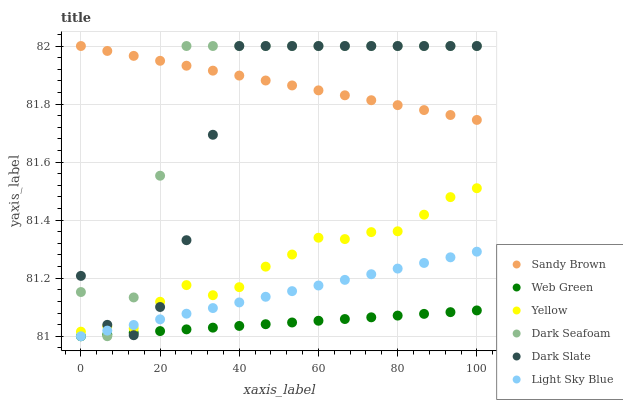Does Web Green have the minimum area under the curve?
Answer yes or no. Yes. Does Sandy Brown have the maximum area under the curve?
Answer yes or no. Yes. Does Dark Slate have the minimum area under the curve?
Answer yes or no. No. Does Dark Slate have the maximum area under the curve?
Answer yes or no. No. Is Web Green the smoothest?
Answer yes or no. Yes. Is Dark Seafoam the roughest?
Answer yes or no. Yes. Is Dark Slate the smoothest?
Answer yes or no. No. Is Dark Slate the roughest?
Answer yes or no. No. Does Light Sky Blue have the lowest value?
Answer yes or no. Yes. Does Dark Slate have the lowest value?
Answer yes or no. No. Does Sandy Brown have the highest value?
Answer yes or no. Yes. Does Light Sky Blue have the highest value?
Answer yes or no. No. Is Light Sky Blue less than Sandy Brown?
Answer yes or no. Yes. Is Yellow greater than Web Green?
Answer yes or no. Yes. Does Dark Slate intersect Dark Seafoam?
Answer yes or no. Yes. Is Dark Slate less than Dark Seafoam?
Answer yes or no. No. Is Dark Slate greater than Dark Seafoam?
Answer yes or no. No. Does Light Sky Blue intersect Sandy Brown?
Answer yes or no. No. 